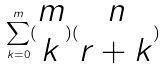<formula> <loc_0><loc_0><loc_500><loc_500>\sum _ { k = 0 } ^ { m } ( \begin{matrix} m \\ k \end{matrix} ) ( \begin{matrix} n \\ r + k \end{matrix} )</formula> 